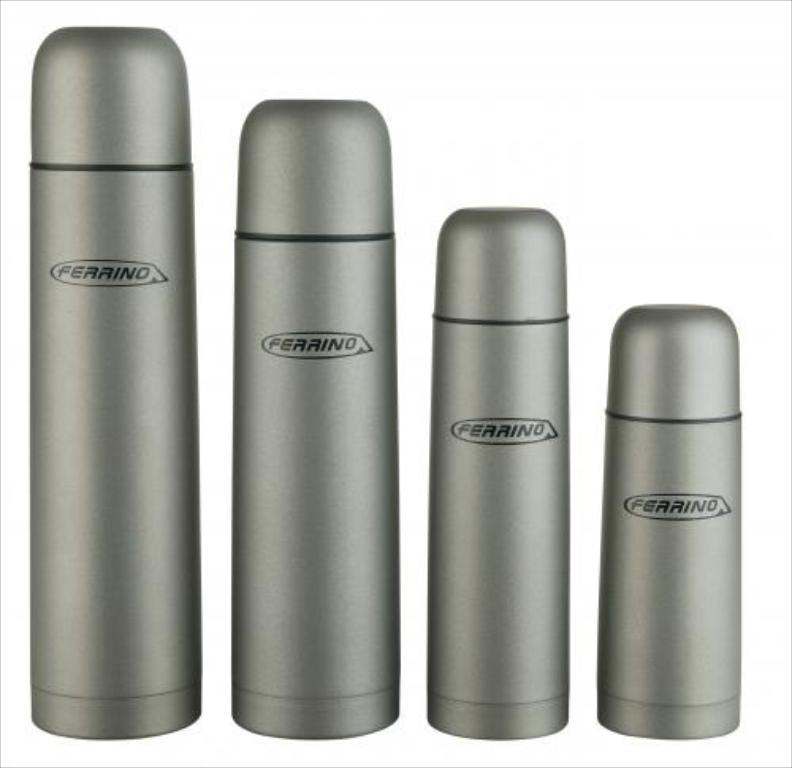How many thermos flask steel bottles are visible in the image? There are four thermos flask steel bottles in the image. What type of record can be seen playing on the turntable in the image? There is no turntable or record present in the image; it only features four thermos flask steel bottles. 